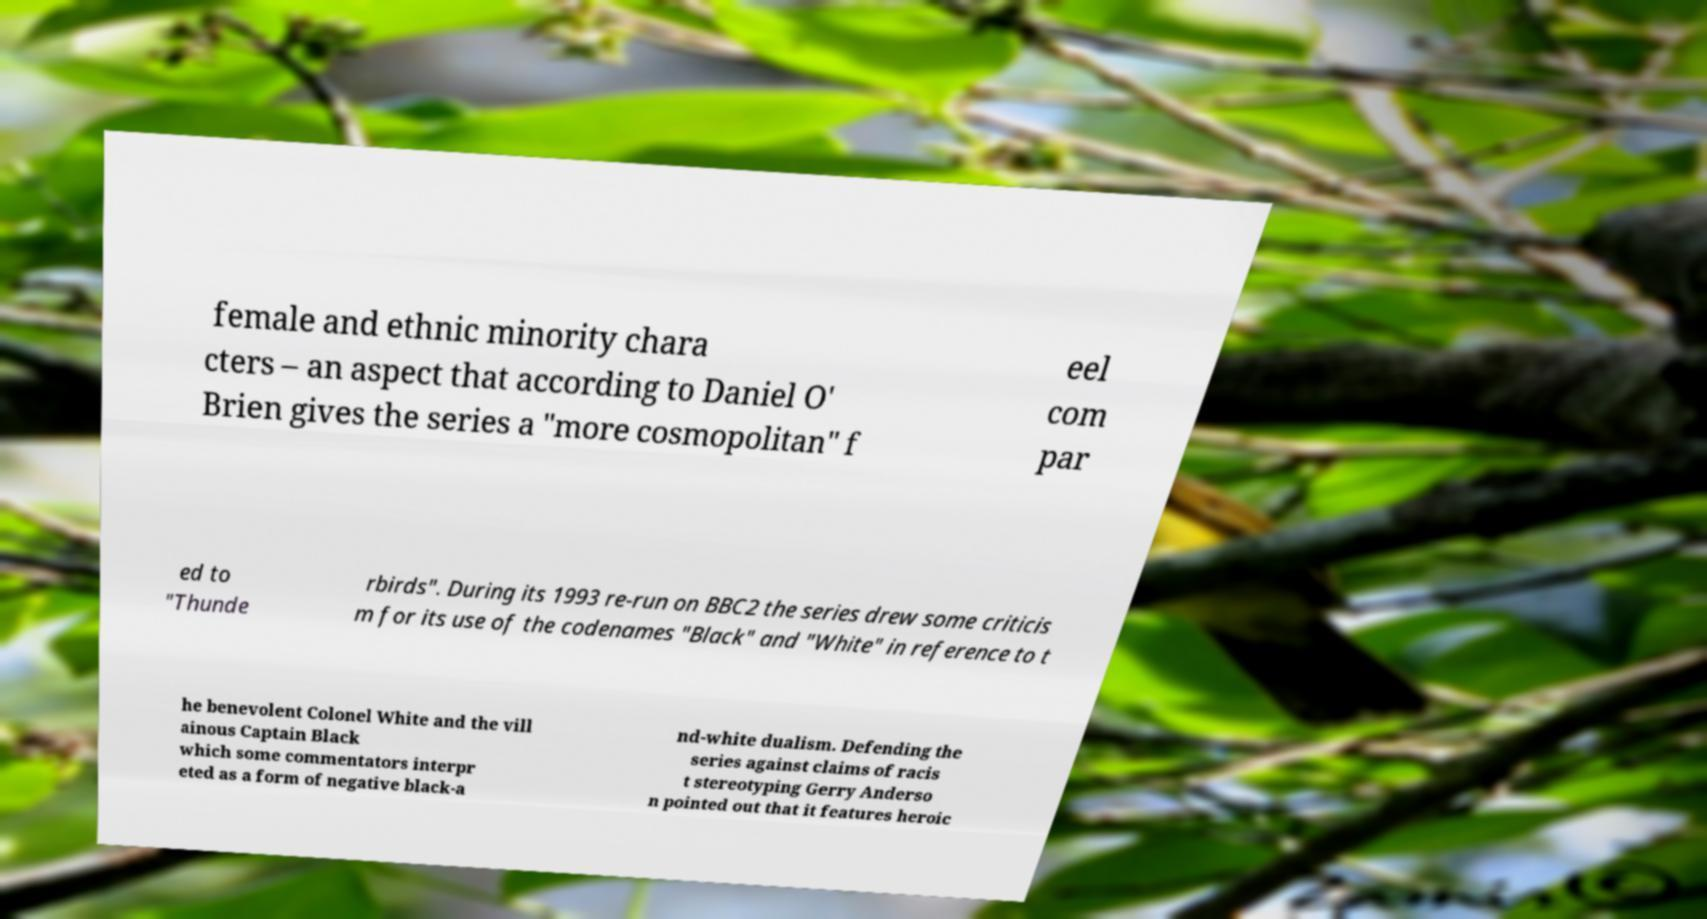I need the written content from this picture converted into text. Can you do that? female and ethnic minority chara cters – an aspect that according to Daniel O' Brien gives the series a "more cosmopolitan" f eel com par ed to "Thunde rbirds". During its 1993 re-run on BBC2 the series drew some criticis m for its use of the codenames "Black" and "White" in reference to t he benevolent Colonel White and the vill ainous Captain Black which some commentators interpr eted as a form of negative black-a nd-white dualism. Defending the series against claims of racis t stereotyping Gerry Anderso n pointed out that it features heroic 